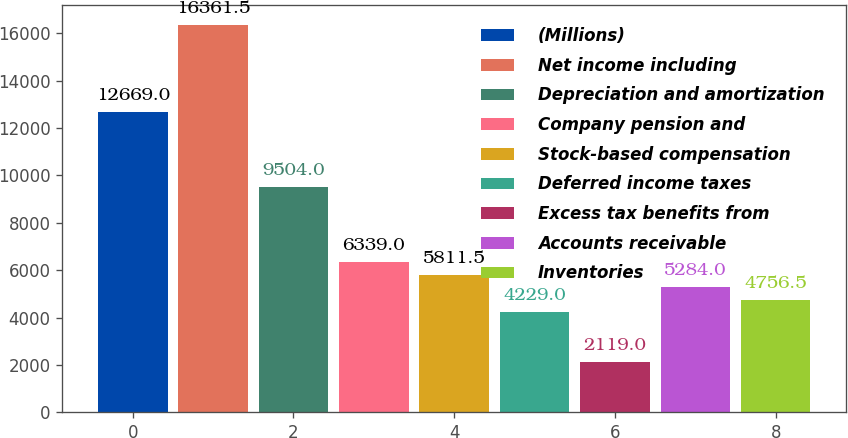Convert chart. <chart><loc_0><loc_0><loc_500><loc_500><bar_chart><fcel>(Millions)<fcel>Net income including<fcel>Depreciation and amortization<fcel>Company pension and<fcel>Stock-based compensation<fcel>Deferred income taxes<fcel>Excess tax benefits from<fcel>Accounts receivable<fcel>Inventories<nl><fcel>12669<fcel>16361.5<fcel>9504<fcel>6339<fcel>5811.5<fcel>4229<fcel>2119<fcel>5284<fcel>4756.5<nl></chart> 